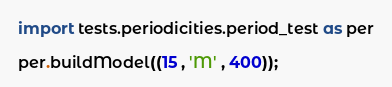Convert code to text. <code><loc_0><loc_0><loc_500><loc_500><_Python_>import tests.periodicities.period_test as per

per.buildModel((15 , 'M' , 400));

</code> 